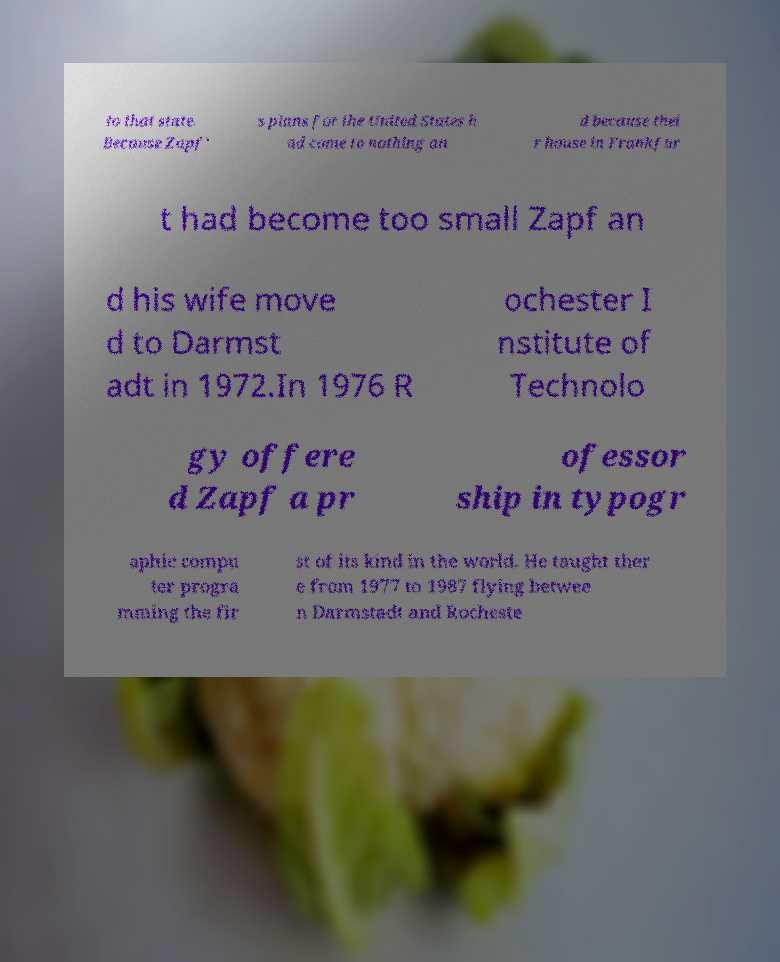Please identify and transcribe the text found in this image. to that state. Because Zapf' s plans for the United States h ad come to nothing an d because thei r house in Frankfur t had become too small Zapf an d his wife move d to Darmst adt in 1972.In 1976 R ochester I nstitute of Technolo gy offere d Zapf a pr ofessor ship in typogr aphic compu ter progra mming the fir st of its kind in the world. He taught ther e from 1977 to 1987 flying betwee n Darmstadt and Rocheste 